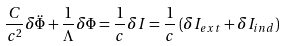<formula> <loc_0><loc_0><loc_500><loc_500>\frac { C } { c ^ { 2 } } \delta \ddot { \Phi } + \frac { 1 } { \Lambda } \delta \Phi = \frac { 1 } { c } \delta I = \frac { 1 } { c } \left ( \delta I _ { e x t } + \delta I _ { i n d } \right )</formula> 